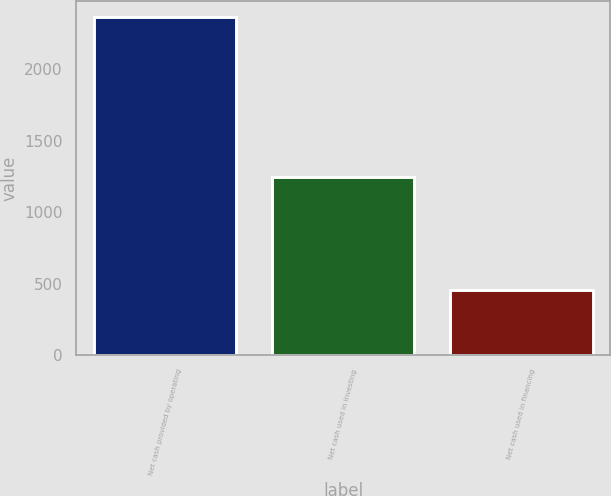Convert chart. <chart><loc_0><loc_0><loc_500><loc_500><bar_chart><fcel>Net cash provided by operating<fcel>Net cash used in investing<fcel>Net cash used in financing<nl><fcel>2362<fcel>1250<fcel>457<nl></chart> 